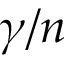Convert formula to latex. <formula><loc_0><loc_0><loc_500><loc_500>\gamma / n</formula> 